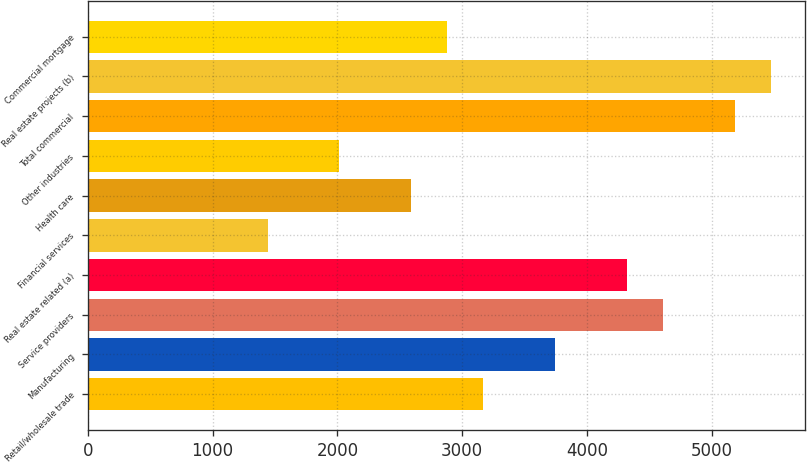Convert chart to OTSL. <chart><loc_0><loc_0><loc_500><loc_500><bar_chart><fcel>Retail/wholesale trade<fcel>Manufacturing<fcel>Service providers<fcel>Real estate related (a)<fcel>Financial services<fcel>Health care<fcel>Other industries<fcel>Total commercial<fcel>Real estate projects (b)<fcel>Commercial mortgage<nl><fcel>3167.95<fcel>3743.79<fcel>4607.55<fcel>4319.63<fcel>1440.43<fcel>2592.11<fcel>2016.27<fcel>5183.39<fcel>5471.31<fcel>2880.03<nl></chart> 